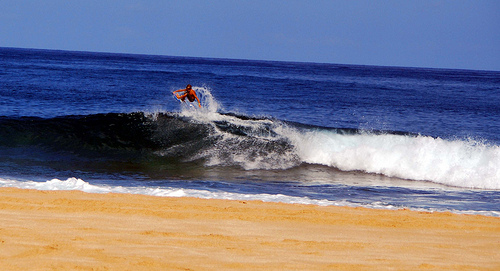Please provide the bounding box coordinate of the region this sentence describes: Man standing on top of surfboard. For an accurate portrait of the surfer's poised position on the surfboard, the precise coordinates are [0.22, 0.31, 0.72, 0.68], ensuring we witness his full stature against the backdrop of the swirling sea. 